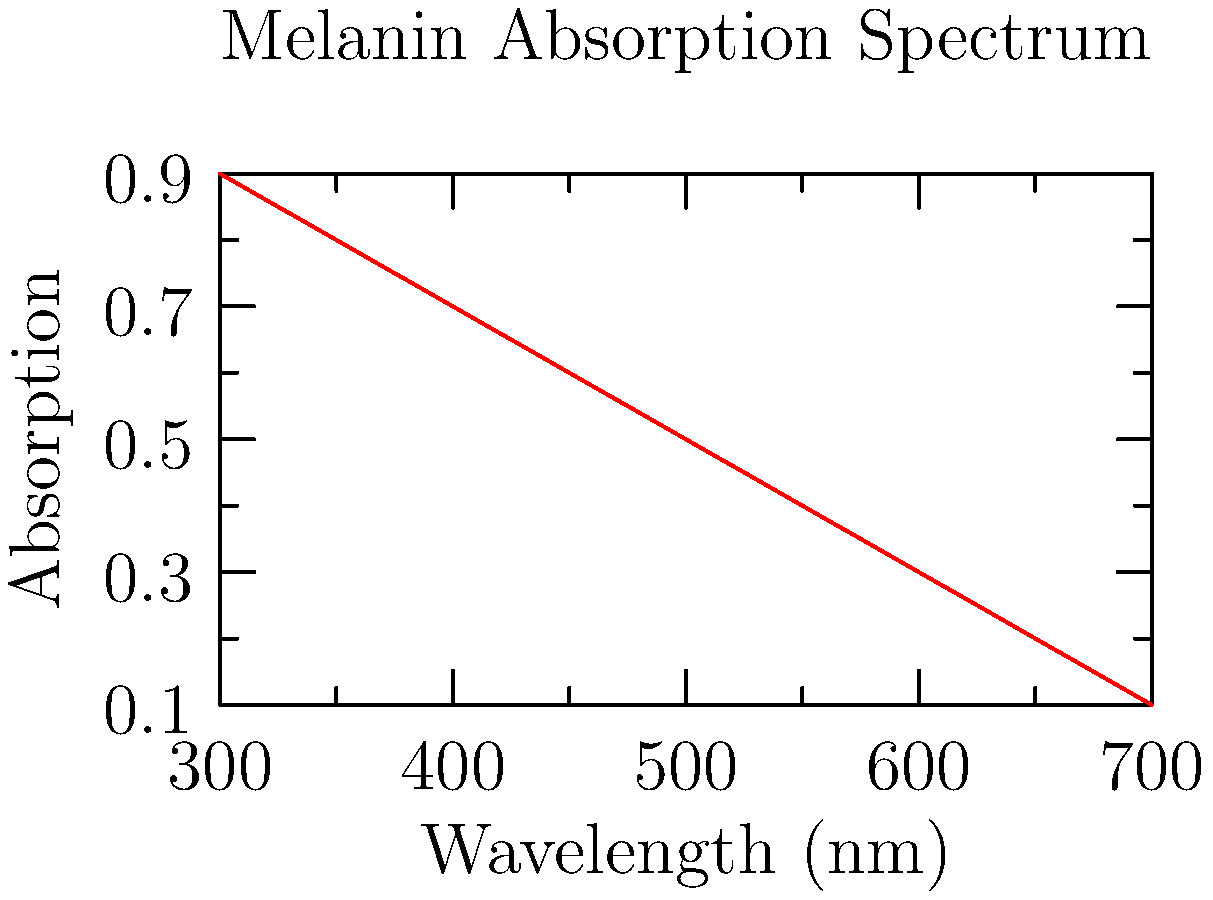Based on the absorption spectrum of melanin shown in the graph, which wavelength range of visible light is most likely to penetrate deeper into the skin, potentially causing more damage to underlying tissues? To answer this question, we need to analyze the absorption spectrum of melanin and understand its implications:

1. The graph shows the absorption spectrum of melanin across different wavelengths of light.
2. The y-axis represents absorption, with higher values indicating greater absorption by melanin.
3. The x-axis represents wavelength in nanometers (nm).
4. Visible light spans approximately 380-700 nm.
5. We observe that the absorption decreases as the wavelength increases.
6. Lower absorption means that light at those wavelengths penetrates deeper into the skin.
7. The graph shows that absorption is lowest at longer wavelengths (towards 700 nm).
8. Longer wavelengths correspond to red light in the visible spectrum.
9. Therefore, red light (600-700 nm) is most likely to penetrate deeper into the skin.
10. Deeper penetration potentially causes more damage to underlying tissues.
Answer: Red light (600-700 nm) 